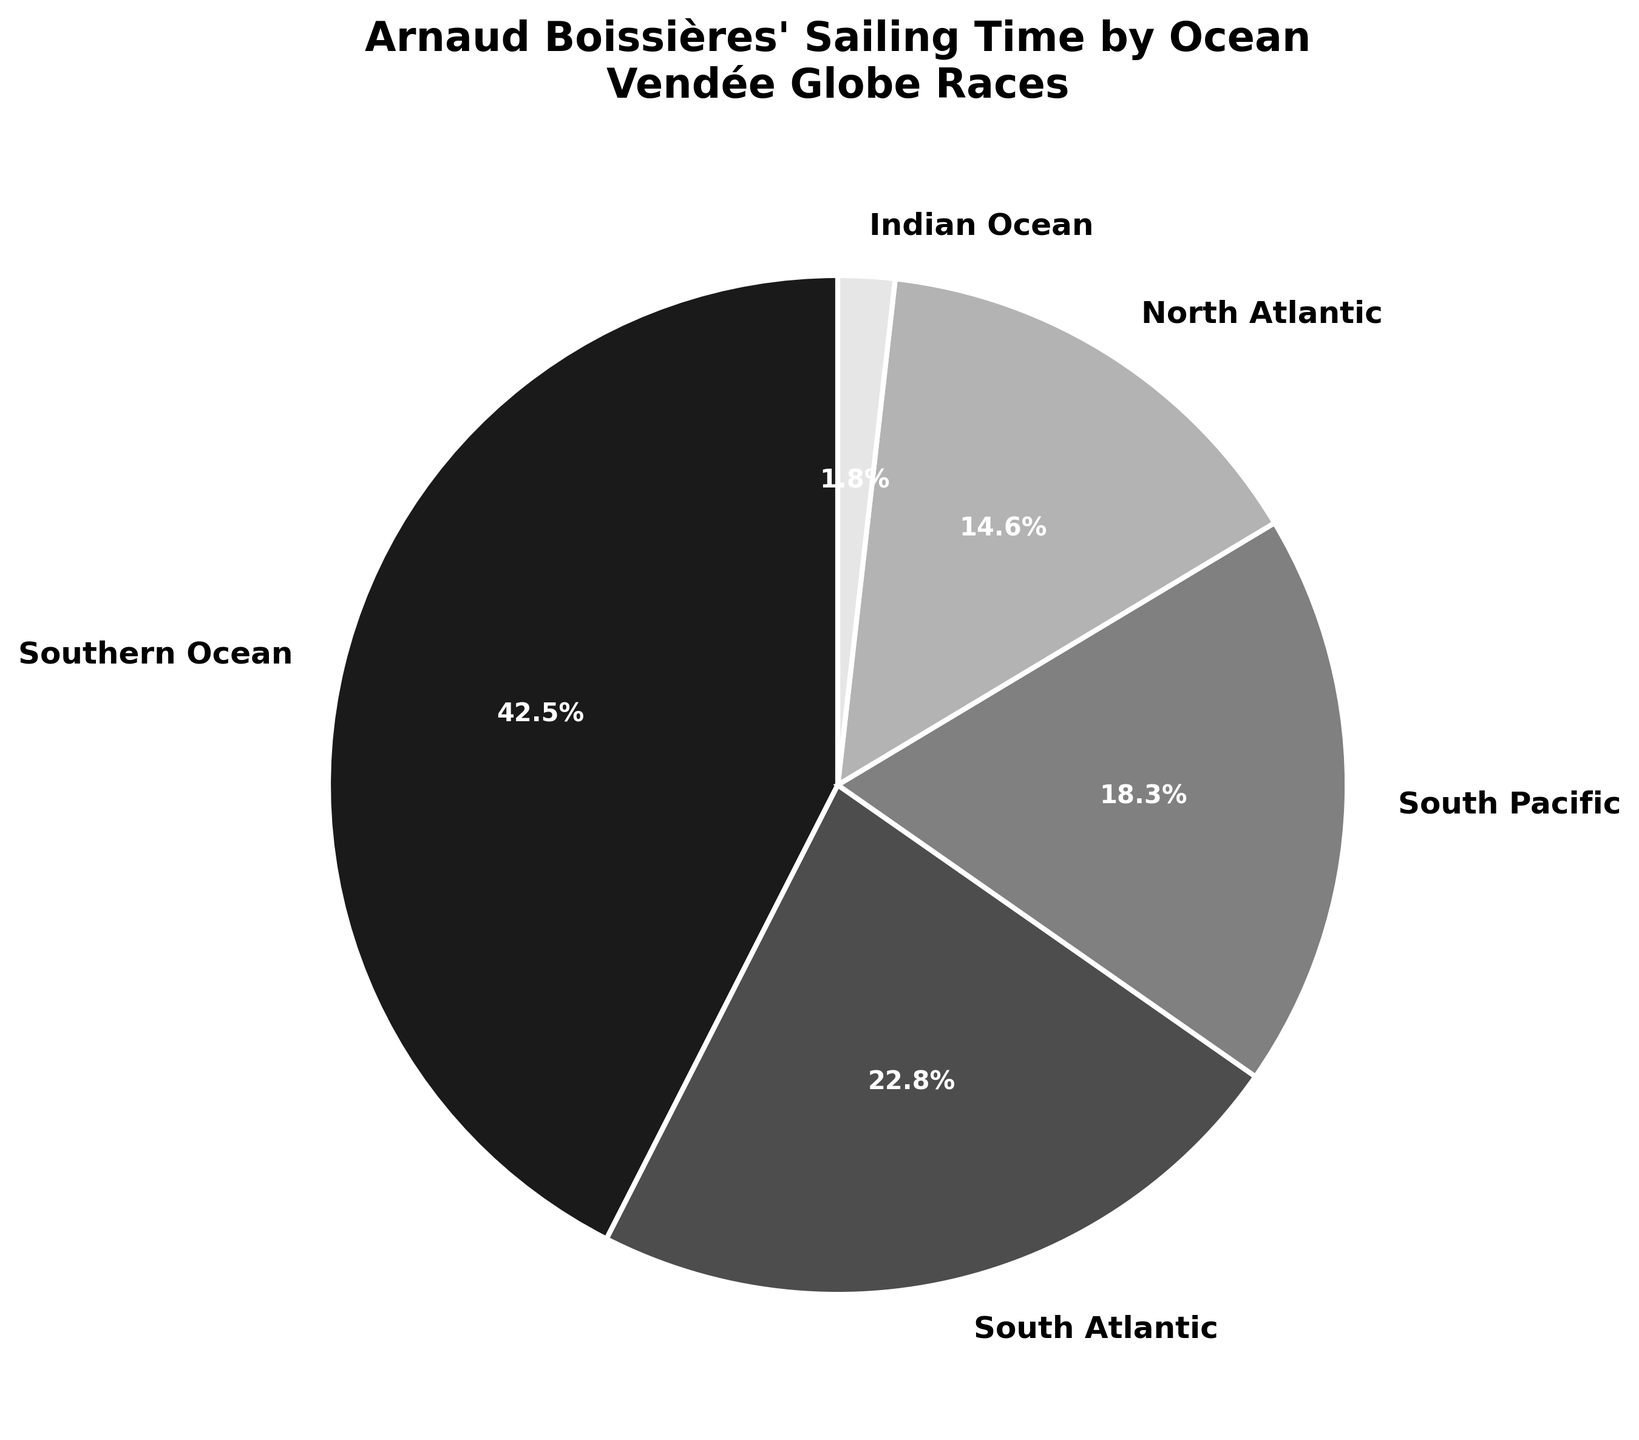Which ocean did Arnaud Boissières spend the most sailing time in? According to the pie chart, the Southern Ocean has the largest share, which is labeled with the highest percentage.
Answer: Southern Ocean Which ocean had the lowest percentage of Arnaud Boissières' total sailing time? The Indian Ocean has the smallest percentage on the pie chart.
Answer: Indian Ocean How much more time did Arnaud Boissières spend in the Southern Ocean compared to the Indian Ocean? The Southern Ocean accounts for 42.5% and the Indian Ocean for 1.8% of his total time. The difference is 42.5% - 1.8% = 40.7%.
Answer: 40.7% Combine the percentages of the South Atlantic and South Pacific Oceans. What is the total? The South Atlantic is 22.8% and the South Pacific is 18.3%. Adding them together results in 22.8% + 18.3% = 41.1%.
Answer: 41.1% Did Arnaud Boissières spend more time in the North Atlantic or the Indian Ocean, and by how much? The North Atlantic accounts for 14.6% of the total sailing time, while the Indian Ocean accounts for 1.8%. The difference is 14.6% - 1.8% = 12.8%.
Answer: North Atlantic by 12.8% What percentage of Arnaud Boissières' total sailing time was spent in oceans other than the Southern Ocean? The total percentage without the Southern Ocean is the sum of the other oceans. 22.8% (South Atlantic) + 18.3% (South Pacific) + 14.6% (North Atlantic) + 1.8% (Indian Ocean) = 57.5%.
Answer: 57.5% By combining the time spent in the South Atlantic and North Atlantic, does Arnaud Boissières spend more time in these combined regions compared to the South Pacific? The combined time for the South Atlantic and North Atlantic is 22.8% + 14.6% = 37.4%, which is greater than the South Pacific's 18.3%.
Answer: Yes What is the approximate ratio of time spent in the Southern Ocean to the South Pacific Ocean? The Southern Ocean accounts for 42.5% and the South Pacific accounts for 18.3%. The ratio is approximately 42.5 / 18.3 ≈ 2.32.
Answer: 2.32 How much total time did Arnaud Boissières spend in the Atlantic Oceans (South and North combined)? Adding the time spent in the South Atlantic (22.8%) and the North Atlantic (14.6%) gives a total of 22.8% + 14.6% = 37.4%.
Answer: 37.4% Which ocean did Arnaud Boissières spend almost a quarter of his total sailing time in? The South Atlantic has a percentage of 22.8%, which is closest to a quarter (25%) compared to the other oceans.
Answer: South Atlantic 